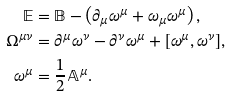Convert formula to latex. <formula><loc_0><loc_0><loc_500><loc_500>\mathbb { E } & = \mathbb { B } - \left ( \partial _ { \mu } \omega ^ { \mu } + \omega _ { \mu } \omega ^ { \mu } \right ) , \\ \Omega ^ { \mu \nu } & = \partial ^ { \mu } \omega ^ { \nu } - \partial ^ { \nu } \omega ^ { \mu } + [ \omega ^ { \mu } , \omega ^ { \nu } ] , \\ \omega ^ { \mu } & = \frac { 1 } { 2 } \mathbb { A } ^ { \mu } .</formula> 